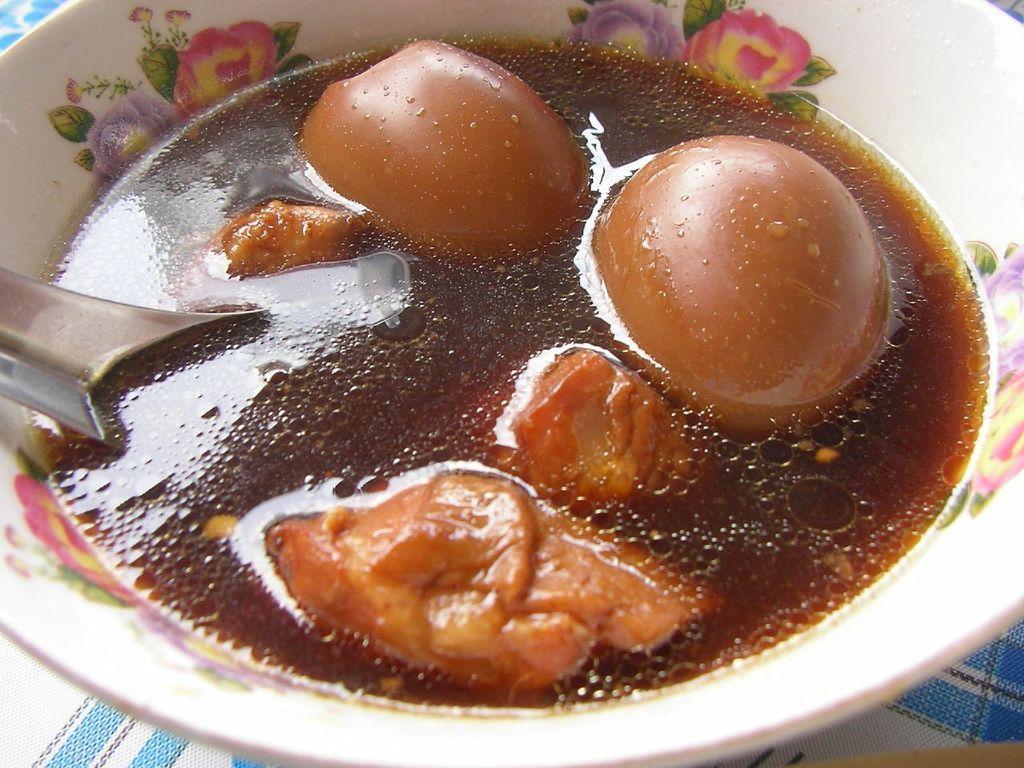Describe this image in one or two sentences. In this image, in the middle there is a bowl in that there are food items, spoon. At the bottom there is a tablecloth. 